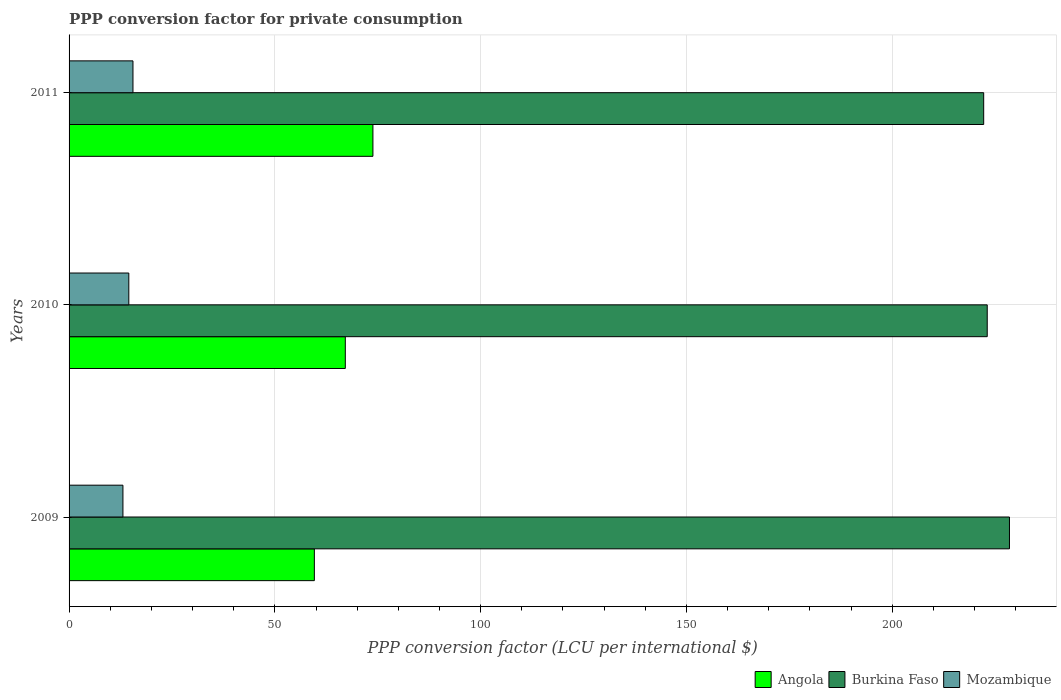How many different coloured bars are there?
Your response must be concise. 3. Are the number of bars per tick equal to the number of legend labels?
Your answer should be compact. Yes. In how many cases, is the number of bars for a given year not equal to the number of legend labels?
Your answer should be very brief. 0. What is the PPP conversion factor for private consumption in Angola in 2009?
Give a very brief answer. 59.6. Across all years, what is the maximum PPP conversion factor for private consumption in Burkina Faso?
Keep it short and to the point. 228.51. Across all years, what is the minimum PPP conversion factor for private consumption in Angola?
Provide a succinct answer. 59.6. In which year was the PPP conversion factor for private consumption in Mozambique minimum?
Offer a very short reply. 2009. What is the total PPP conversion factor for private consumption in Burkina Faso in the graph?
Offer a very short reply. 673.85. What is the difference between the PPP conversion factor for private consumption in Burkina Faso in 2009 and that in 2011?
Your answer should be compact. 6.26. What is the difference between the PPP conversion factor for private consumption in Angola in 2010 and the PPP conversion factor for private consumption in Burkina Faso in 2009?
Make the answer very short. -161.38. What is the average PPP conversion factor for private consumption in Mozambique per year?
Offer a terse response. 14.38. In the year 2009, what is the difference between the PPP conversion factor for private consumption in Burkina Faso and PPP conversion factor for private consumption in Angola?
Provide a short and direct response. 168.91. In how many years, is the PPP conversion factor for private consumption in Angola greater than 180 LCU?
Provide a succinct answer. 0. What is the ratio of the PPP conversion factor for private consumption in Burkina Faso in 2009 to that in 2011?
Give a very brief answer. 1.03. Is the difference between the PPP conversion factor for private consumption in Burkina Faso in 2009 and 2011 greater than the difference between the PPP conversion factor for private consumption in Angola in 2009 and 2011?
Provide a short and direct response. Yes. What is the difference between the highest and the second highest PPP conversion factor for private consumption in Angola?
Your response must be concise. 6.71. What is the difference between the highest and the lowest PPP conversion factor for private consumption in Angola?
Make the answer very short. 14.23. In how many years, is the PPP conversion factor for private consumption in Angola greater than the average PPP conversion factor for private consumption in Angola taken over all years?
Provide a short and direct response. 2. What does the 3rd bar from the top in 2009 represents?
Give a very brief answer. Angola. What does the 2nd bar from the bottom in 2010 represents?
Provide a short and direct response. Burkina Faso. Is it the case that in every year, the sum of the PPP conversion factor for private consumption in Mozambique and PPP conversion factor for private consumption in Burkina Faso is greater than the PPP conversion factor for private consumption in Angola?
Provide a succinct answer. Yes. How many bars are there?
Give a very brief answer. 9. Are all the bars in the graph horizontal?
Your answer should be very brief. Yes. What is the difference between two consecutive major ticks on the X-axis?
Ensure brevity in your answer.  50. Are the values on the major ticks of X-axis written in scientific E-notation?
Offer a very short reply. No. Does the graph contain grids?
Your response must be concise. Yes. Where does the legend appear in the graph?
Your answer should be compact. Bottom right. What is the title of the graph?
Make the answer very short. PPP conversion factor for private consumption. Does "Timor-Leste" appear as one of the legend labels in the graph?
Provide a succinct answer. No. What is the label or title of the X-axis?
Your answer should be very brief. PPP conversion factor (LCU per international $). What is the label or title of the Y-axis?
Give a very brief answer. Years. What is the PPP conversion factor (LCU per international $) of Angola in 2009?
Your answer should be very brief. 59.6. What is the PPP conversion factor (LCU per international $) in Burkina Faso in 2009?
Keep it short and to the point. 228.51. What is the PPP conversion factor (LCU per international $) in Mozambique in 2009?
Ensure brevity in your answer.  13.09. What is the PPP conversion factor (LCU per international $) of Angola in 2010?
Your response must be concise. 67.12. What is the PPP conversion factor (LCU per international $) in Burkina Faso in 2010?
Your response must be concise. 223.1. What is the PPP conversion factor (LCU per international $) in Mozambique in 2010?
Your answer should be compact. 14.51. What is the PPP conversion factor (LCU per international $) of Angola in 2011?
Give a very brief answer. 73.83. What is the PPP conversion factor (LCU per international $) of Burkina Faso in 2011?
Provide a short and direct response. 222.24. What is the PPP conversion factor (LCU per international $) of Mozambique in 2011?
Give a very brief answer. 15.53. Across all years, what is the maximum PPP conversion factor (LCU per international $) in Angola?
Your answer should be very brief. 73.83. Across all years, what is the maximum PPP conversion factor (LCU per international $) of Burkina Faso?
Your answer should be very brief. 228.51. Across all years, what is the maximum PPP conversion factor (LCU per international $) in Mozambique?
Your answer should be very brief. 15.53. Across all years, what is the minimum PPP conversion factor (LCU per international $) of Angola?
Your response must be concise. 59.6. Across all years, what is the minimum PPP conversion factor (LCU per international $) in Burkina Faso?
Make the answer very short. 222.24. Across all years, what is the minimum PPP conversion factor (LCU per international $) in Mozambique?
Offer a terse response. 13.09. What is the total PPP conversion factor (LCU per international $) in Angola in the graph?
Offer a very short reply. 200.56. What is the total PPP conversion factor (LCU per international $) of Burkina Faso in the graph?
Provide a short and direct response. 673.85. What is the total PPP conversion factor (LCU per international $) in Mozambique in the graph?
Give a very brief answer. 43.13. What is the difference between the PPP conversion factor (LCU per international $) of Angola in 2009 and that in 2010?
Provide a succinct answer. -7.52. What is the difference between the PPP conversion factor (LCU per international $) in Burkina Faso in 2009 and that in 2010?
Ensure brevity in your answer.  5.41. What is the difference between the PPP conversion factor (LCU per international $) of Mozambique in 2009 and that in 2010?
Your answer should be very brief. -1.42. What is the difference between the PPP conversion factor (LCU per international $) in Angola in 2009 and that in 2011?
Your answer should be very brief. -14.23. What is the difference between the PPP conversion factor (LCU per international $) of Burkina Faso in 2009 and that in 2011?
Make the answer very short. 6.26. What is the difference between the PPP conversion factor (LCU per international $) in Mozambique in 2009 and that in 2011?
Give a very brief answer. -2.44. What is the difference between the PPP conversion factor (LCU per international $) in Angola in 2010 and that in 2011?
Keep it short and to the point. -6.71. What is the difference between the PPP conversion factor (LCU per international $) of Burkina Faso in 2010 and that in 2011?
Offer a very short reply. 0.86. What is the difference between the PPP conversion factor (LCU per international $) of Mozambique in 2010 and that in 2011?
Make the answer very short. -1.01. What is the difference between the PPP conversion factor (LCU per international $) of Angola in 2009 and the PPP conversion factor (LCU per international $) of Burkina Faso in 2010?
Offer a very short reply. -163.5. What is the difference between the PPP conversion factor (LCU per international $) of Angola in 2009 and the PPP conversion factor (LCU per international $) of Mozambique in 2010?
Give a very brief answer. 45.09. What is the difference between the PPP conversion factor (LCU per international $) in Burkina Faso in 2009 and the PPP conversion factor (LCU per international $) in Mozambique in 2010?
Ensure brevity in your answer.  213.99. What is the difference between the PPP conversion factor (LCU per international $) in Angola in 2009 and the PPP conversion factor (LCU per international $) in Burkina Faso in 2011?
Your answer should be compact. -162.64. What is the difference between the PPP conversion factor (LCU per international $) of Angola in 2009 and the PPP conversion factor (LCU per international $) of Mozambique in 2011?
Your response must be concise. 44.07. What is the difference between the PPP conversion factor (LCU per international $) in Burkina Faso in 2009 and the PPP conversion factor (LCU per international $) in Mozambique in 2011?
Your response must be concise. 212.98. What is the difference between the PPP conversion factor (LCU per international $) in Angola in 2010 and the PPP conversion factor (LCU per international $) in Burkina Faso in 2011?
Your answer should be compact. -155.12. What is the difference between the PPP conversion factor (LCU per international $) in Angola in 2010 and the PPP conversion factor (LCU per international $) in Mozambique in 2011?
Offer a very short reply. 51.6. What is the difference between the PPP conversion factor (LCU per international $) in Burkina Faso in 2010 and the PPP conversion factor (LCU per international $) in Mozambique in 2011?
Provide a succinct answer. 207.57. What is the average PPP conversion factor (LCU per international $) in Angola per year?
Make the answer very short. 66.85. What is the average PPP conversion factor (LCU per international $) in Burkina Faso per year?
Keep it short and to the point. 224.62. What is the average PPP conversion factor (LCU per international $) in Mozambique per year?
Your response must be concise. 14.38. In the year 2009, what is the difference between the PPP conversion factor (LCU per international $) of Angola and PPP conversion factor (LCU per international $) of Burkina Faso?
Provide a short and direct response. -168.91. In the year 2009, what is the difference between the PPP conversion factor (LCU per international $) in Angola and PPP conversion factor (LCU per international $) in Mozambique?
Provide a short and direct response. 46.51. In the year 2009, what is the difference between the PPP conversion factor (LCU per international $) in Burkina Faso and PPP conversion factor (LCU per international $) in Mozambique?
Offer a very short reply. 215.42. In the year 2010, what is the difference between the PPP conversion factor (LCU per international $) in Angola and PPP conversion factor (LCU per international $) in Burkina Faso?
Your answer should be very brief. -155.98. In the year 2010, what is the difference between the PPP conversion factor (LCU per international $) in Angola and PPP conversion factor (LCU per international $) in Mozambique?
Your answer should be very brief. 52.61. In the year 2010, what is the difference between the PPP conversion factor (LCU per international $) of Burkina Faso and PPP conversion factor (LCU per international $) of Mozambique?
Provide a short and direct response. 208.59. In the year 2011, what is the difference between the PPP conversion factor (LCU per international $) of Angola and PPP conversion factor (LCU per international $) of Burkina Faso?
Keep it short and to the point. -148.41. In the year 2011, what is the difference between the PPP conversion factor (LCU per international $) of Angola and PPP conversion factor (LCU per international $) of Mozambique?
Ensure brevity in your answer.  58.31. In the year 2011, what is the difference between the PPP conversion factor (LCU per international $) of Burkina Faso and PPP conversion factor (LCU per international $) of Mozambique?
Your answer should be compact. 206.71. What is the ratio of the PPP conversion factor (LCU per international $) of Angola in 2009 to that in 2010?
Make the answer very short. 0.89. What is the ratio of the PPP conversion factor (LCU per international $) in Burkina Faso in 2009 to that in 2010?
Offer a terse response. 1.02. What is the ratio of the PPP conversion factor (LCU per international $) in Mozambique in 2009 to that in 2010?
Your response must be concise. 0.9. What is the ratio of the PPP conversion factor (LCU per international $) in Angola in 2009 to that in 2011?
Your answer should be compact. 0.81. What is the ratio of the PPP conversion factor (LCU per international $) of Burkina Faso in 2009 to that in 2011?
Give a very brief answer. 1.03. What is the ratio of the PPP conversion factor (LCU per international $) in Mozambique in 2009 to that in 2011?
Give a very brief answer. 0.84. What is the ratio of the PPP conversion factor (LCU per international $) in Angola in 2010 to that in 2011?
Offer a terse response. 0.91. What is the ratio of the PPP conversion factor (LCU per international $) in Mozambique in 2010 to that in 2011?
Keep it short and to the point. 0.93. What is the difference between the highest and the second highest PPP conversion factor (LCU per international $) in Angola?
Provide a succinct answer. 6.71. What is the difference between the highest and the second highest PPP conversion factor (LCU per international $) in Burkina Faso?
Offer a terse response. 5.41. What is the difference between the highest and the second highest PPP conversion factor (LCU per international $) in Mozambique?
Your answer should be compact. 1.01. What is the difference between the highest and the lowest PPP conversion factor (LCU per international $) of Angola?
Your answer should be compact. 14.23. What is the difference between the highest and the lowest PPP conversion factor (LCU per international $) of Burkina Faso?
Ensure brevity in your answer.  6.26. What is the difference between the highest and the lowest PPP conversion factor (LCU per international $) of Mozambique?
Offer a very short reply. 2.44. 